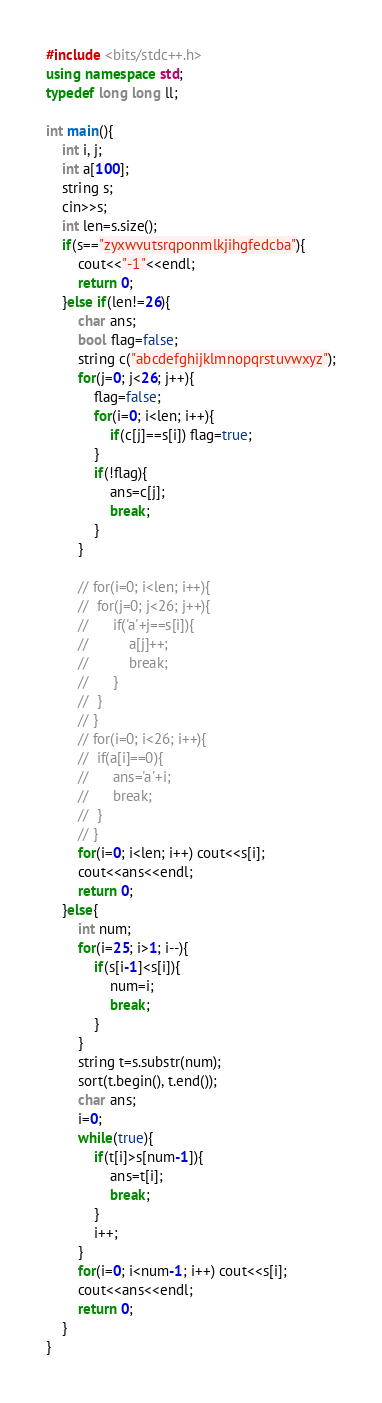<code> <loc_0><loc_0><loc_500><loc_500><_C++_>#include <bits/stdc++.h>
using namespace std;
typedef long long ll;

int main(){
	int i, j;
	int a[100];
	string s;
	cin>>s;
	int len=s.size();
	if(s=="zyxwvutsrqponmlkjihgfedcba"){
		cout<<"-1"<<endl;
		return 0;
	}else if(len!=26){
		char ans;
		bool flag=false;
		string c("abcdefghijklmnopqrstuvwxyz");
		for(j=0; j<26; j++){
			flag=false;
			for(i=0; i<len; i++){
				if(c[j]==s[i]) flag=true;
			}
			if(!flag){
				ans=c[j];
				break;
			}
		}

		// for(i=0; i<len; i++){
		// 	for(j=0; j<26; j++){
		// 		if('a'+j==s[i]){
		// 			a[j]++;
		// 			break;
		// 		}
		// 	}
		// }
		// for(i=0; i<26; i++){
		// 	if(a[i]==0){
		// 		ans='a'+i;
		// 		break;
		// 	}
		// }
		for(i=0; i<len; i++) cout<<s[i];
		cout<<ans<<endl;
		return 0;
	}else{
		int num;
		for(i=25; i>1; i--){
			if(s[i-1]<s[i]){
				num=i;
				break;
			}
		}
		string t=s.substr(num);
		sort(t.begin(), t.end());
		char ans;
		i=0;
		while(true){
			if(t[i]>s[num-1]){
				ans=t[i];
				break;
			}
			i++;
		}
		for(i=0; i<num-1; i++) cout<<s[i];
		cout<<ans<<endl;
		return 0;
	}
}</code> 